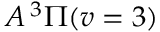Convert formula to latex. <formula><loc_0><loc_0><loc_500><loc_500>A ^ { 3 } \Pi ( v = 3 )</formula> 